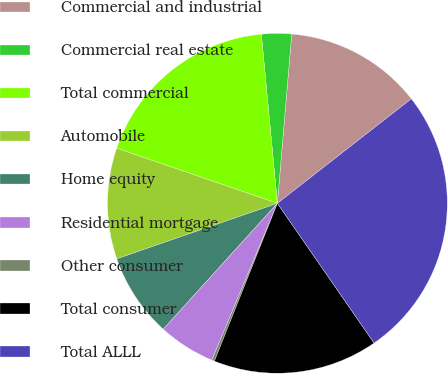<chart> <loc_0><loc_0><loc_500><loc_500><pie_chart><fcel>Commercial and industrial<fcel>Commercial real estate<fcel>Total commercial<fcel>Automobile<fcel>Home equity<fcel>Residential mortgage<fcel>Other consumer<fcel>Total consumer<fcel>Total ALLL<nl><fcel>13.11%<fcel>2.85%<fcel>18.24%<fcel>10.55%<fcel>7.98%<fcel>5.42%<fcel>0.26%<fcel>15.68%<fcel>25.91%<nl></chart> 